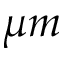Convert formula to latex. <formula><loc_0><loc_0><loc_500><loc_500>\mu m</formula> 